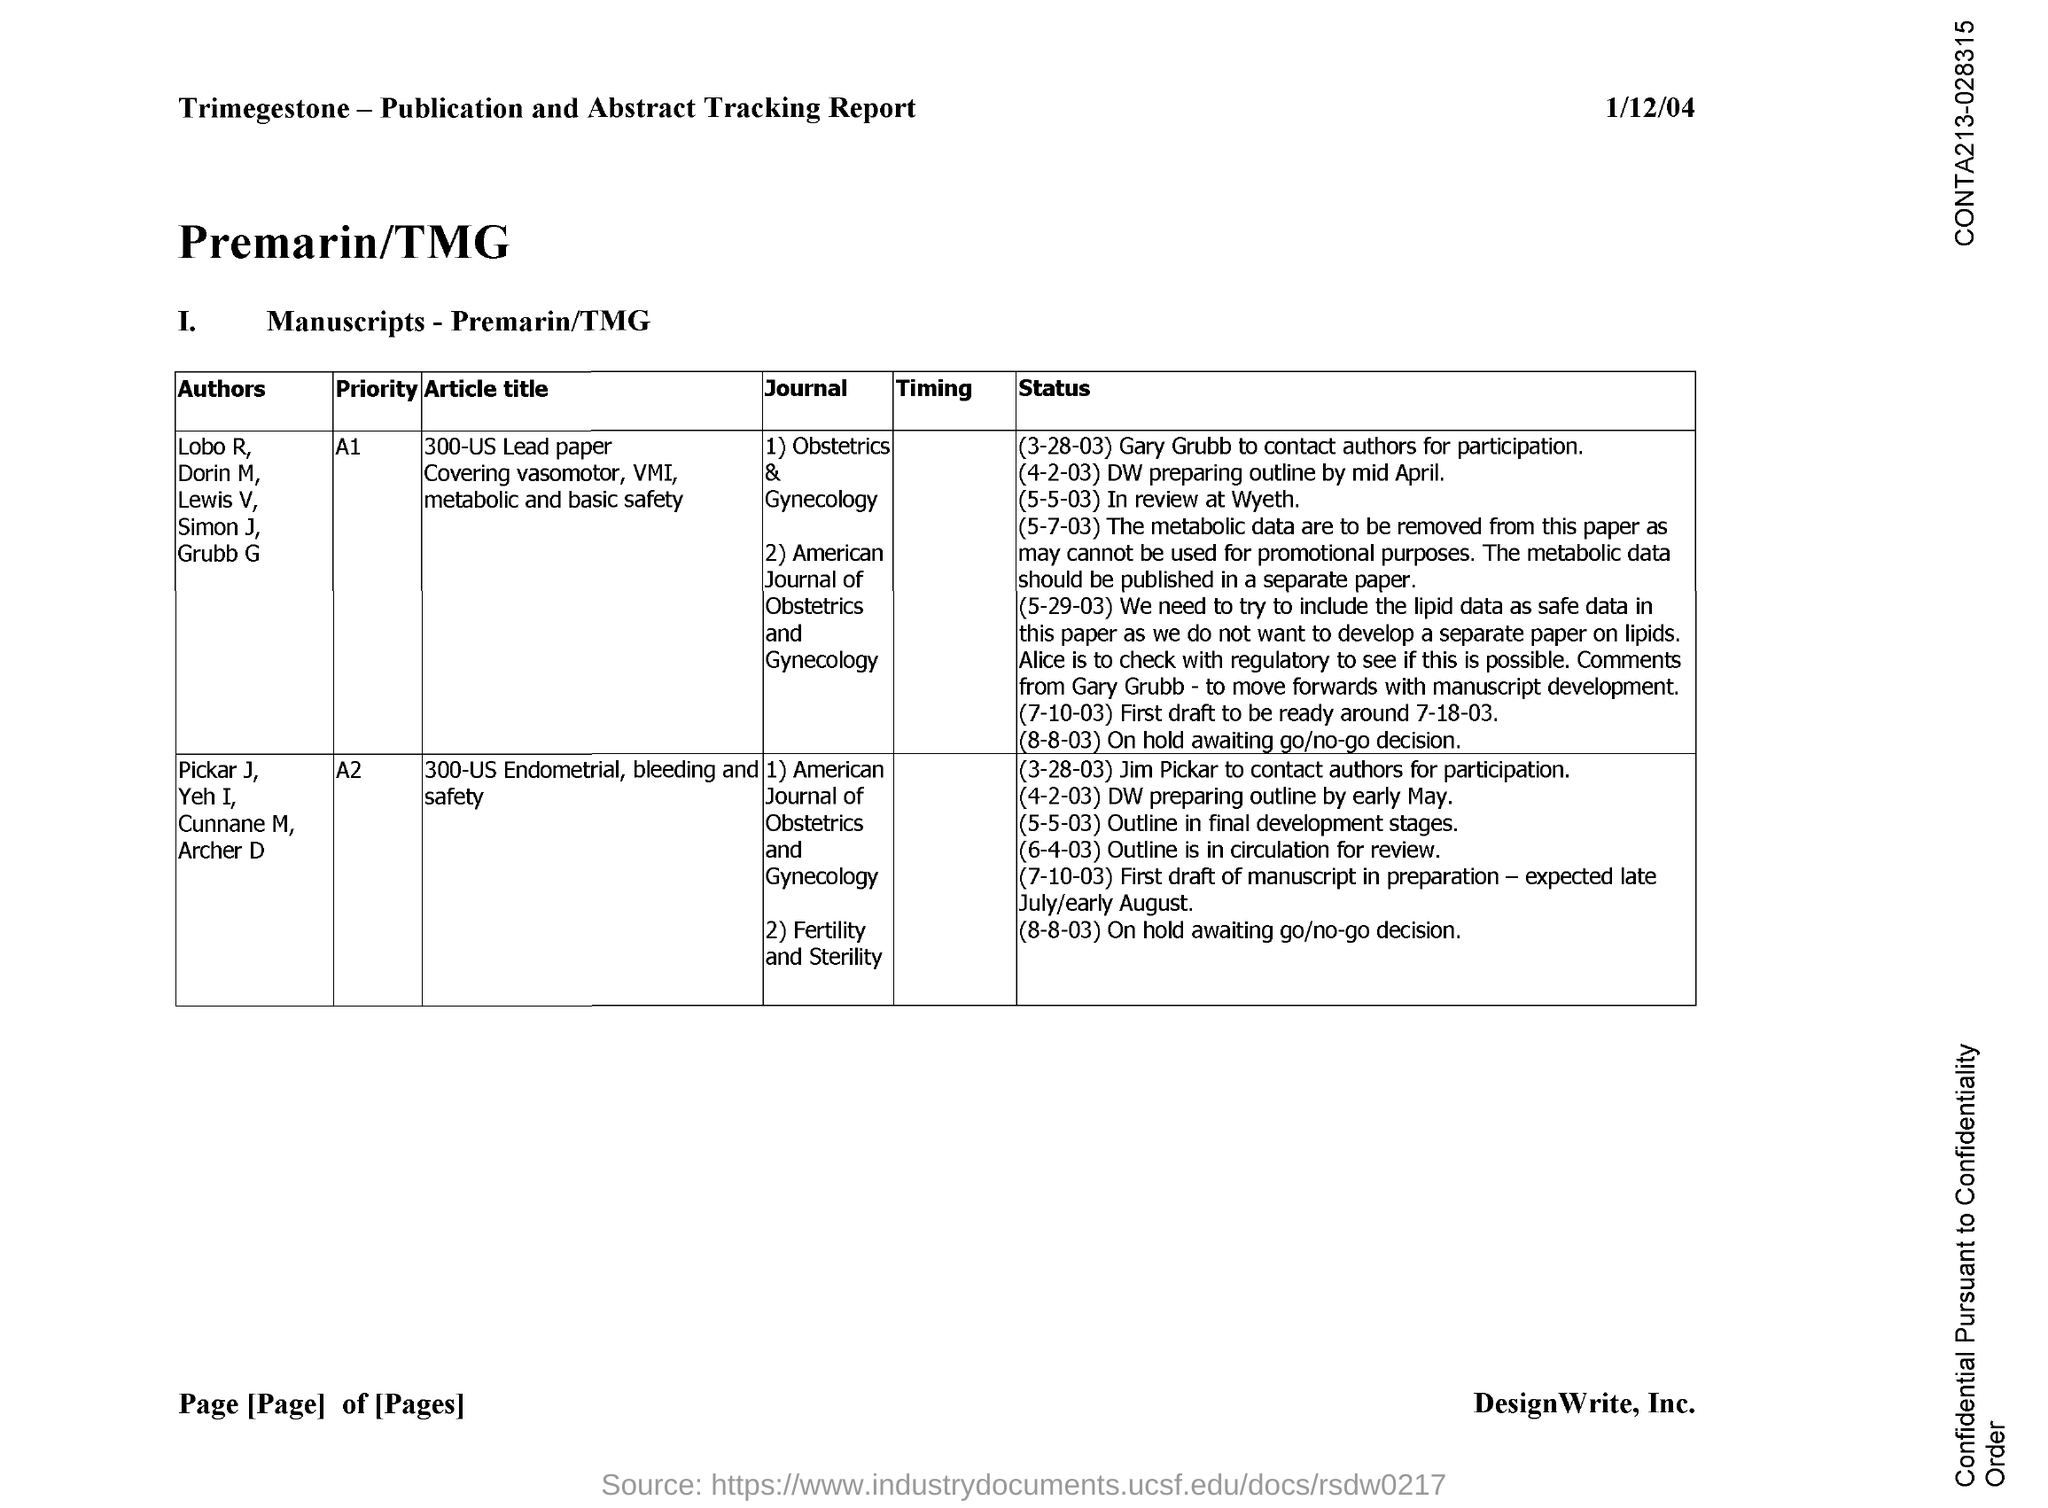Outline some significant characteristics in this image. A 300-US Lead paper that covers vasomotor, VMI, metabolic, and basic safety issues has a priority of A1. The second journal in a series of 300 articles on topics related to lead, vasomotor, metabolic, and basic safety in pregnant women is the American Journal of Obstetrics and Gynecology. The second journal in a series of three focused on 300-US Endometrial, bleeding, and safety is "Fertility and Sterility. The first journal to cover topics related to 300-US lead paper covering vasomotor, VMI, metabolic, and basic safety is "Obstetrics & Gynecology. The priority of 300-US Endometrial, bleeding and safety is A2. 